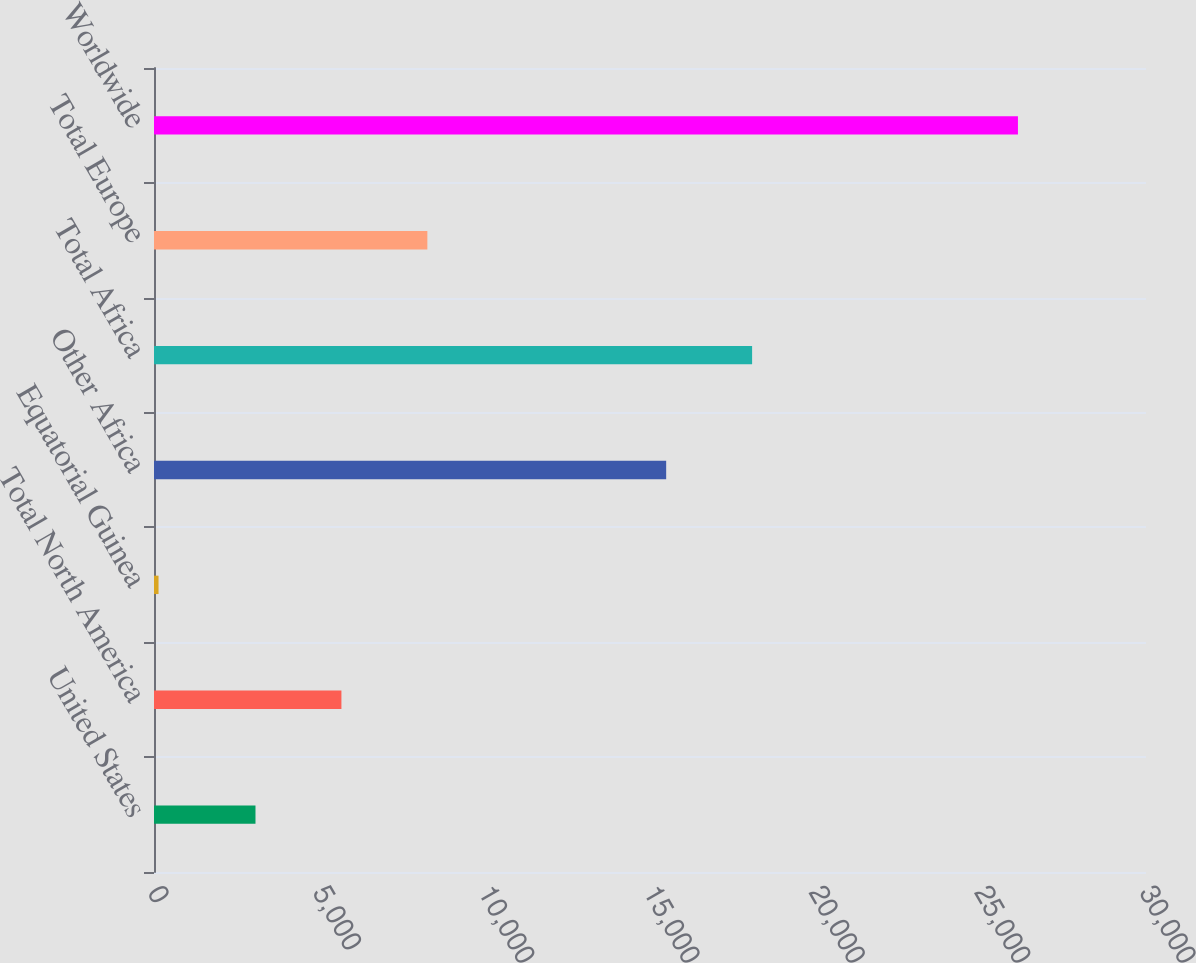<chart> <loc_0><loc_0><loc_500><loc_500><bar_chart><fcel>United States<fcel>Total North America<fcel>Equatorial Guinea<fcel>Other Africa<fcel>Total Africa<fcel>Total Europe<fcel>Worldwide<nl><fcel>3069<fcel>5668<fcel>137<fcel>15489<fcel>18088<fcel>8267<fcel>26127<nl></chart> 